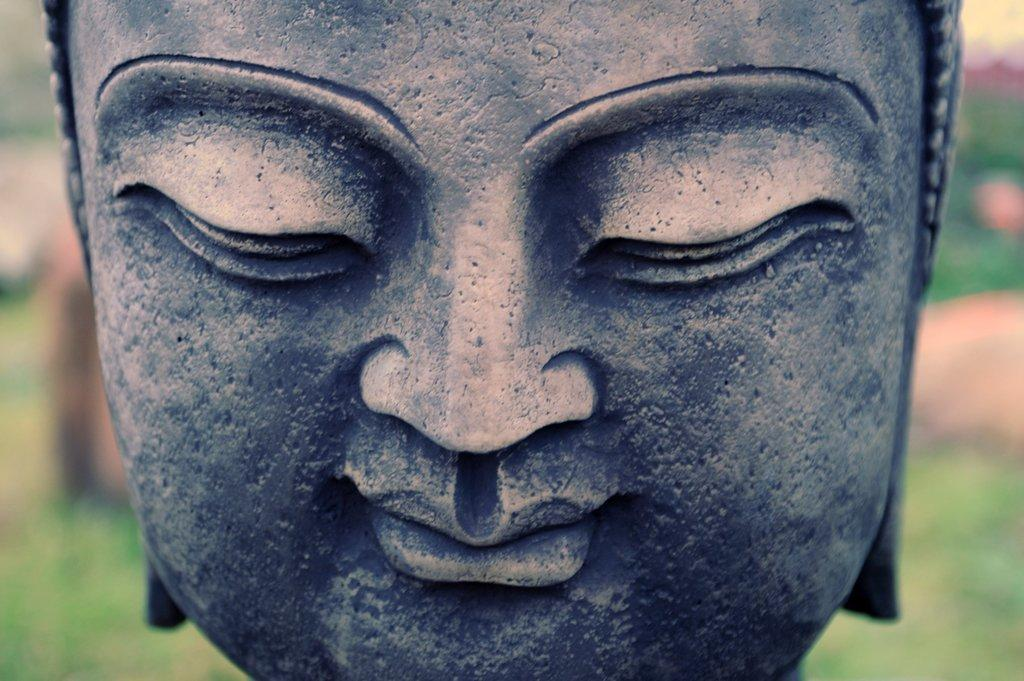What is the main subject of the image? There is a statue in the image. What color is the statue? The statue is gray in color. Can you describe the background of the image? The background of the image is blurred. What type of tree can be seen in the background of the image? There is no tree visible in the image; the background is blurred. What time of day is it in the image, given the morning light? There is no indication of the time of day in the image, as the lighting is not described. 